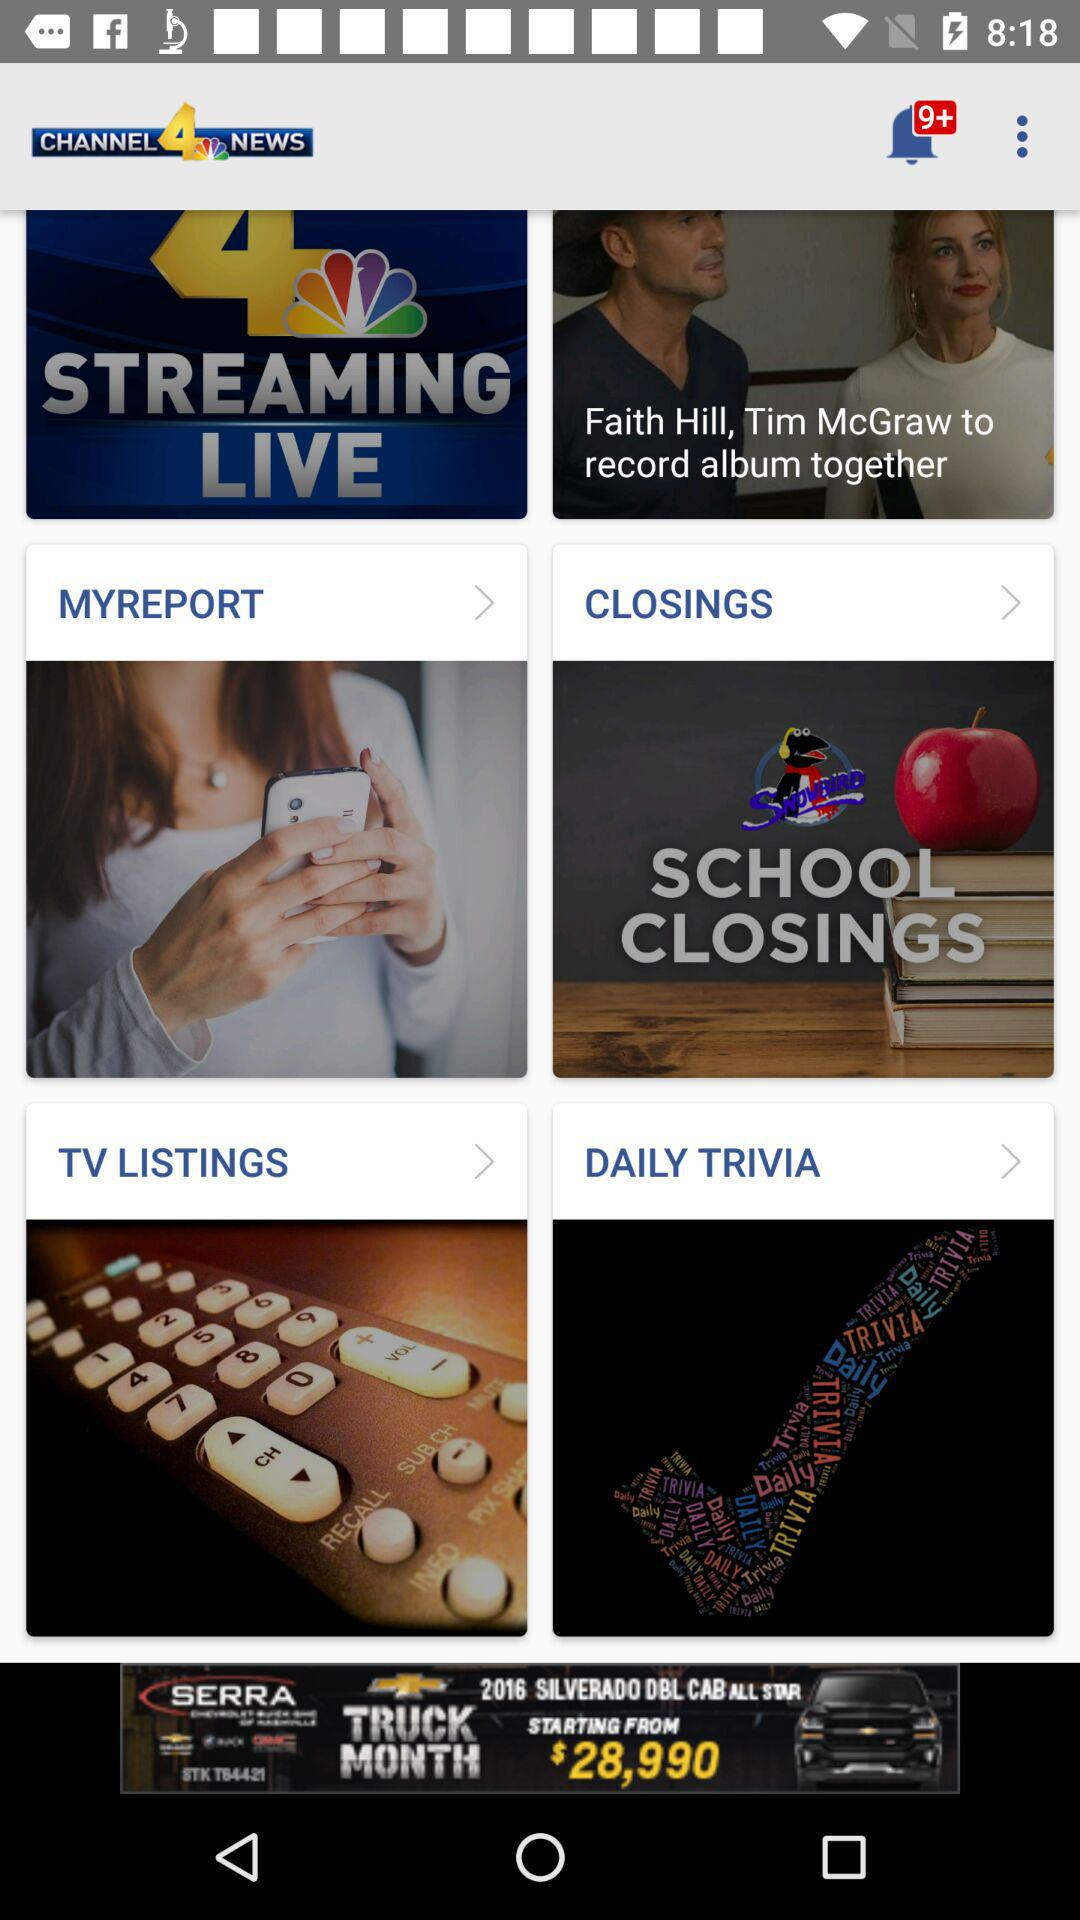How many notifications are there? There are more than 9 notifications. 